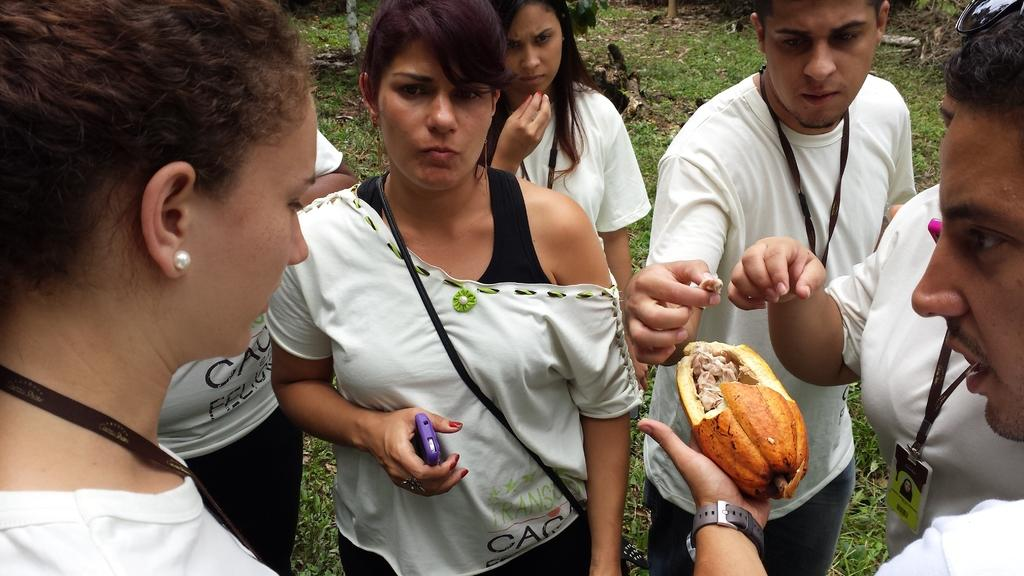How many people are in the image? There are people in the image, but the exact number is not specified. What is the person holding in his hand? The person is holding a fruit in his hand. What can be seen in the background of the image? There is grass visible in the background of the image. What type of zebra can be seen transporting a button in the image? There is no zebra or button present in the image. 